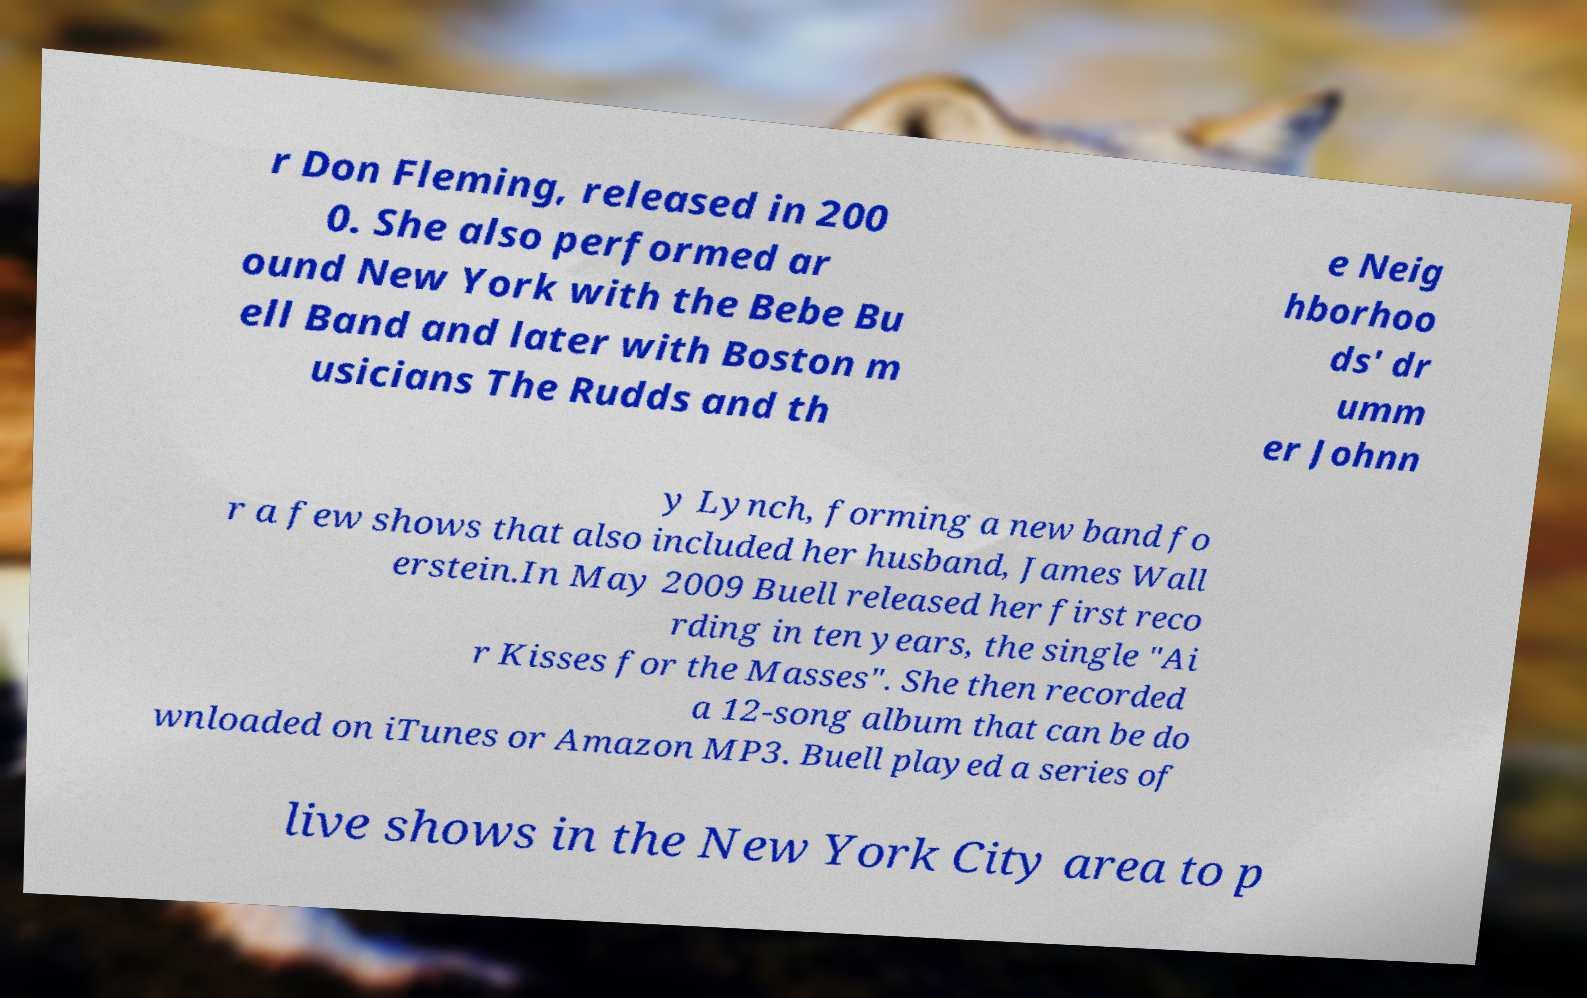I need the written content from this picture converted into text. Can you do that? r Don Fleming, released in 200 0. She also performed ar ound New York with the Bebe Bu ell Band and later with Boston m usicians The Rudds and th e Neig hborhoo ds' dr umm er Johnn y Lynch, forming a new band fo r a few shows that also included her husband, James Wall erstein.In May 2009 Buell released her first reco rding in ten years, the single "Ai r Kisses for the Masses". She then recorded a 12-song album that can be do wnloaded on iTunes or Amazon MP3. Buell played a series of live shows in the New York City area to p 